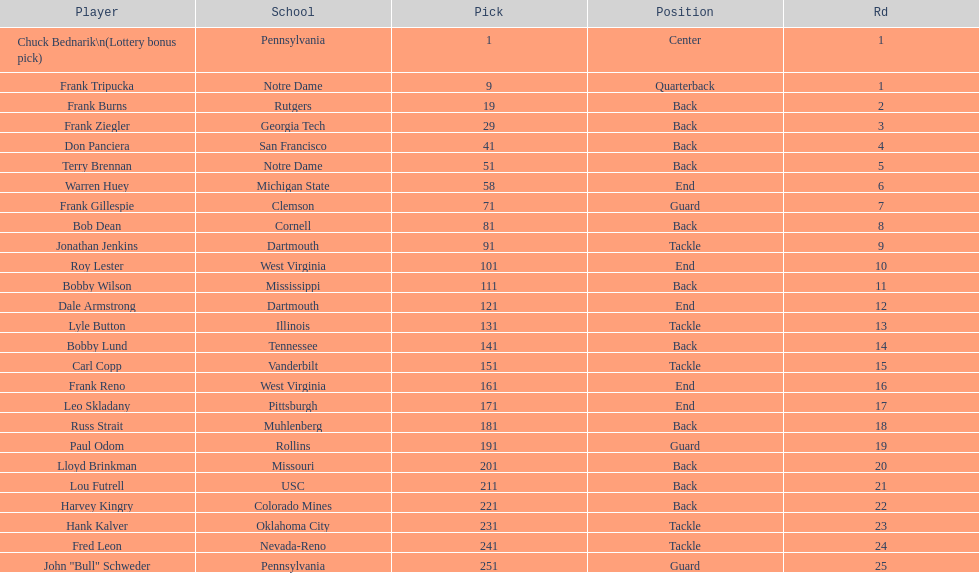Who was the player that the team drafted after bob dean? Jonathan Jenkins. 